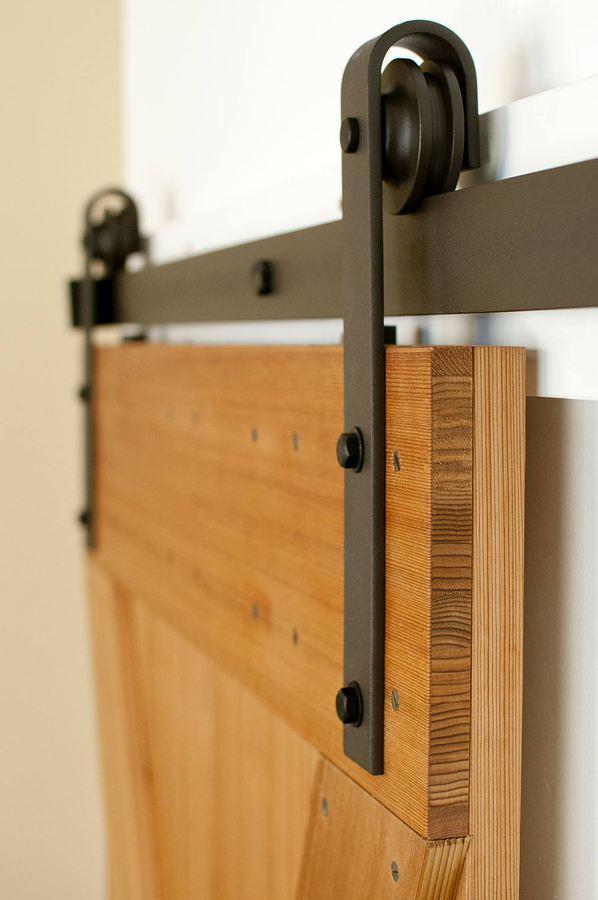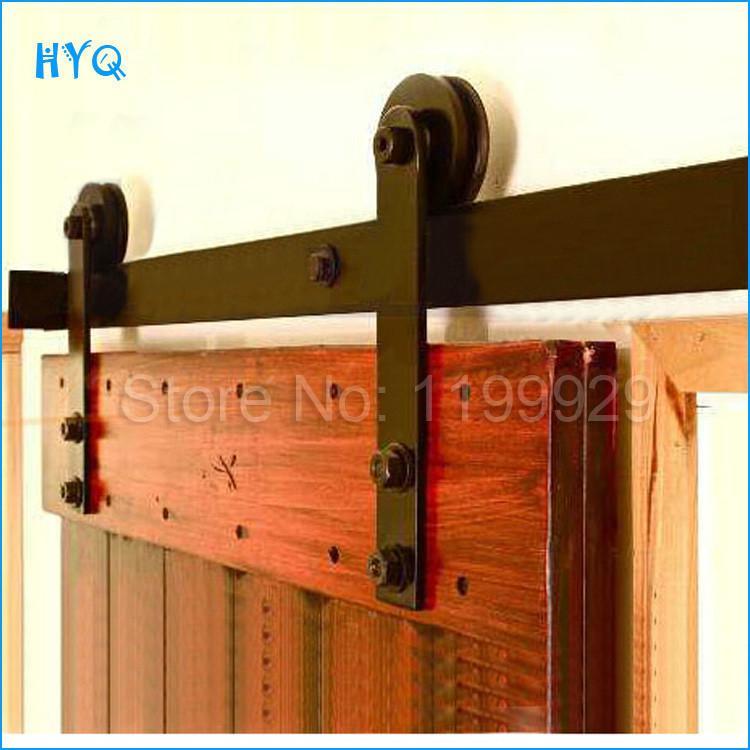The first image is the image on the left, the second image is the image on the right. Considering the images on both sides, is "The door section shown in the left image is not displayed at an angle." valid? Answer yes or no. No. 